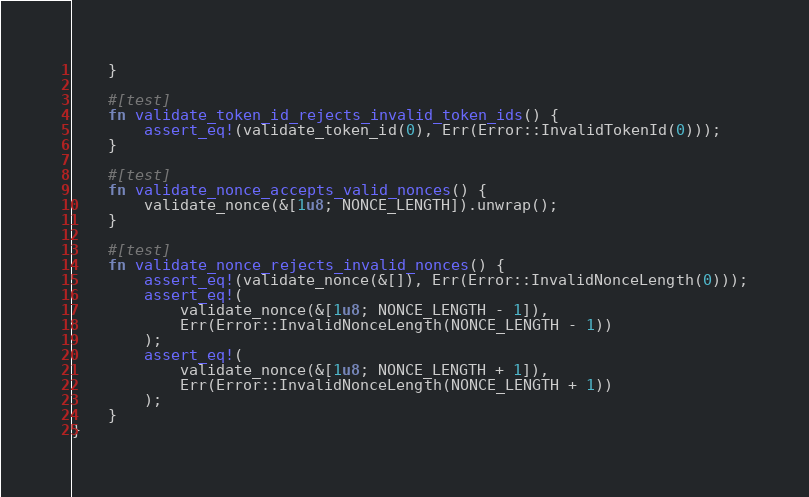<code> <loc_0><loc_0><loc_500><loc_500><_Rust_>    }

    #[test]
    fn validate_token_id_rejects_invalid_token_ids() {
        assert_eq!(validate_token_id(0), Err(Error::InvalidTokenId(0)));
    }

    #[test]
    fn validate_nonce_accepts_valid_nonces() {
        validate_nonce(&[1u8; NONCE_LENGTH]).unwrap();
    }

    #[test]
    fn validate_nonce_rejects_invalid_nonces() {
        assert_eq!(validate_nonce(&[]), Err(Error::InvalidNonceLength(0)));
        assert_eq!(
            validate_nonce(&[1u8; NONCE_LENGTH - 1]),
            Err(Error::InvalidNonceLength(NONCE_LENGTH - 1))
        );
        assert_eq!(
            validate_nonce(&[1u8; NONCE_LENGTH + 1]),
            Err(Error::InvalidNonceLength(NONCE_LENGTH + 1))
        );
    }
}
</code> 